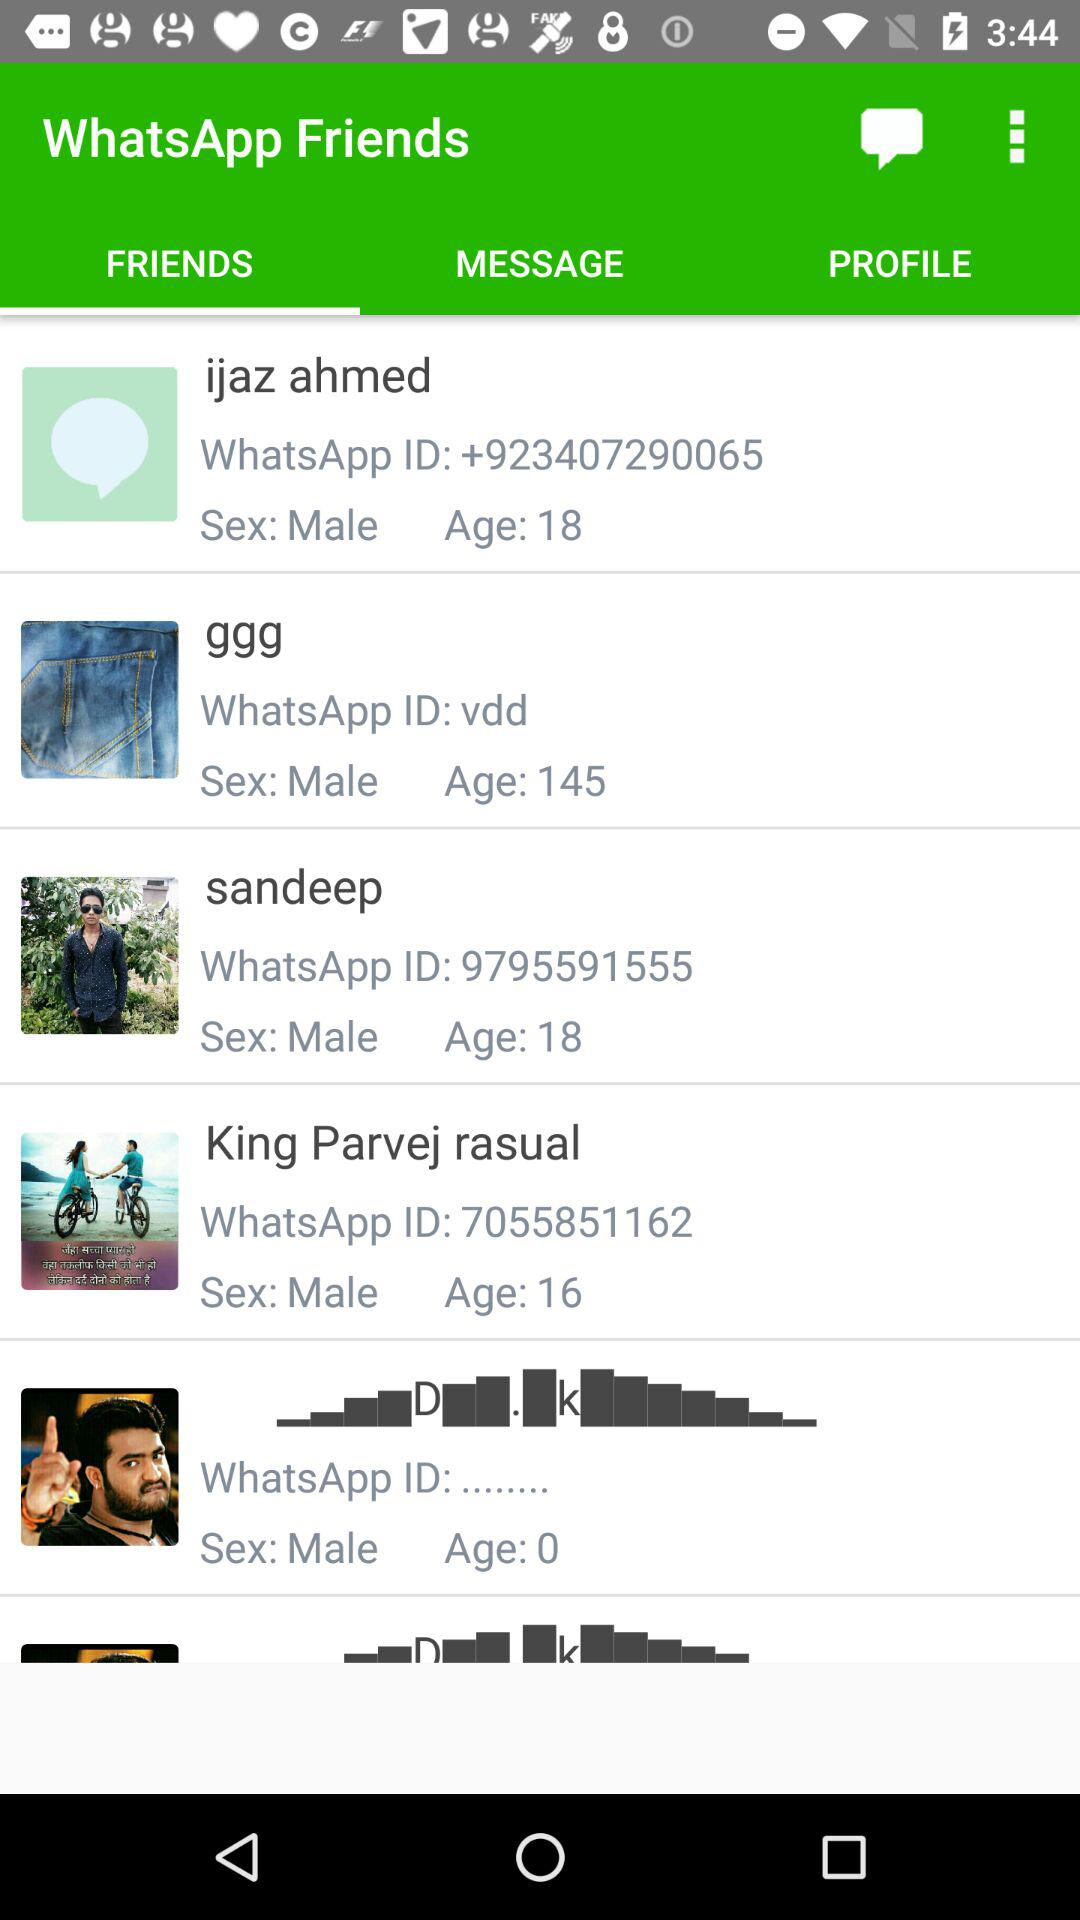How many people are in the age group 16-18?
Answer the question using a single word or phrase. 3 